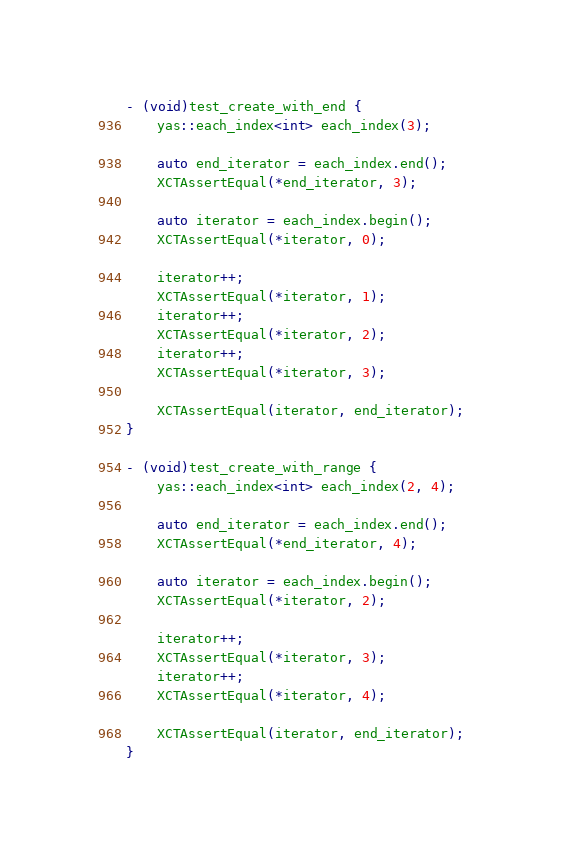<code> <loc_0><loc_0><loc_500><loc_500><_ObjectiveC_>- (void)test_create_with_end {
    yas::each_index<int> each_index(3);

    auto end_iterator = each_index.end();
    XCTAssertEqual(*end_iterator, 3);

    auto iterator = each_index.begin();
    XCTAssertEqual(*iterator, 0);

    iterator++;
    XCTAssertEqual(*iterator, 1);
    iterator++;
    XCTAssertEqual(*iterator, 2);
    iterator++;
    XCTAssertEqual(*iterator, 3);

    XCTAssertEqual(iterator, end_iterator);
}

- (void)test_create_with_range {
    yas::each_index<int> each_index(2, 4);

    auto end_iterator = each_index.end();
    XCTAssertEqual(*end_iterator, 4);

    auto iterator = each_index.begin();
    XCTAssertEqual(*iterator, 2);

    iterator++;
    XCTAssertEqual(*iterator, 3);
    iterator++;
    XCTAssertEqual(*iterator, 4);

    XCTAssertEqual(iterator, end_iterator);
}
</code> 